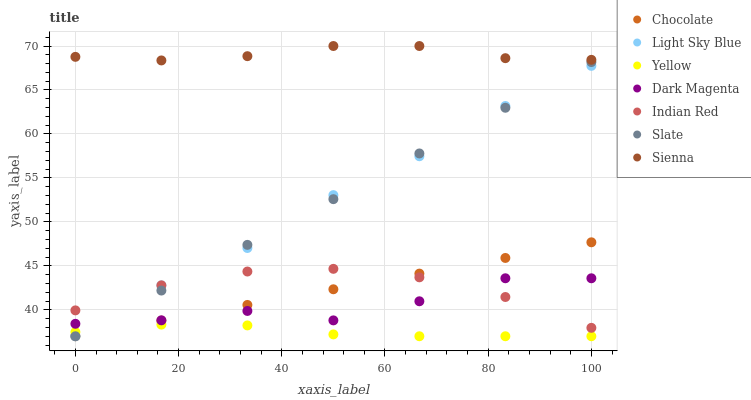Does Yellow have the minimum area under the curve?
Answer yes or no. Yes. Does Sienna have the maximum area under the curve?
Answer yes or no. Yes. Does Slate have the minimum area under the curve?
Answer yes or no. No. Does Slate have the maximum area under the curve?
Answer yes or no. No. Is Chocolate the smoothest?
Answer yes or no. Yes. Is Dark Magenta the roughest?
Answer yes or no. Yes. Is Slate the smoothest?
Answer yes or no. No. Is Slate the roughest?
Answer yes or no. No. Does Slate have the lowest value?
Answer yes or no. Yes. Does Sienna have the lowest value?
Answer yes or no. No. Does Sienna have the highest value?
Answer yes or no. Yes. Does Slate have the highest value?
Answer yes or no. No. Is Indian Red less than Sienna?
Answer yes or no. Yes. Is Sienna greater than Yellow?
Answer yes or no. Yes. Does Chocolate intersect Yellow?
Answer yes or no. Yes. Is Chocolate less than Yellow?
Answer yes or no. No. Is Chocolate greater than Yellow?
Answer yes or no. No. Does Indian Red intersect Sienna?
Answer yes or no. No. 